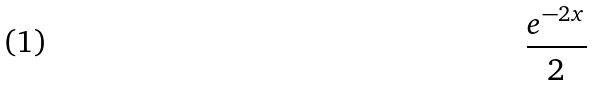<formula> <loc_0><loc_0><loc_500><loc_500>\frac { e ^ { - 2 x } } { 2 }</formula> 